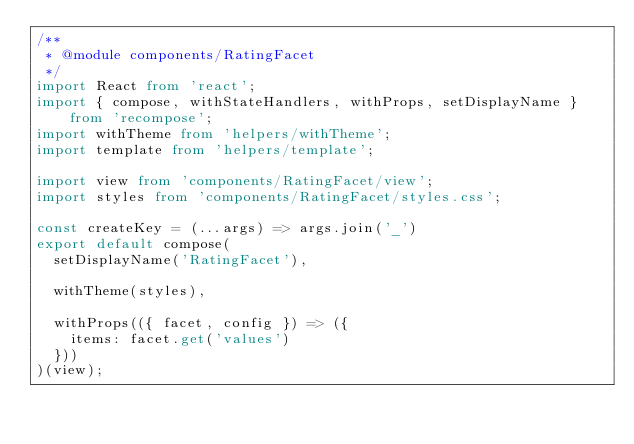Convert code to text. <code><loc_0><loc_0><loc_500><loc_500><_TypeScript_>/**
 * @module components/RatingFacet
 */
import React from 'react';
import { compose, withStateHandlers, withProps, setDisplayName } from 'recompose';
import withTheme from 'helpers/withTheme';
import template from 'helpers/template';

import view from 'components/RatingFacet/view';
import styles from 'components/RatingFacet/styles.css';

const createKey = (...args) => args.join('_')
export default compose(
  setDisplayName('RatingFacet'),

  withTheme(styles),

  withProps(({ facet, config }) => ({
    items: facet.get('values')
  }))
)(view);
</code> 